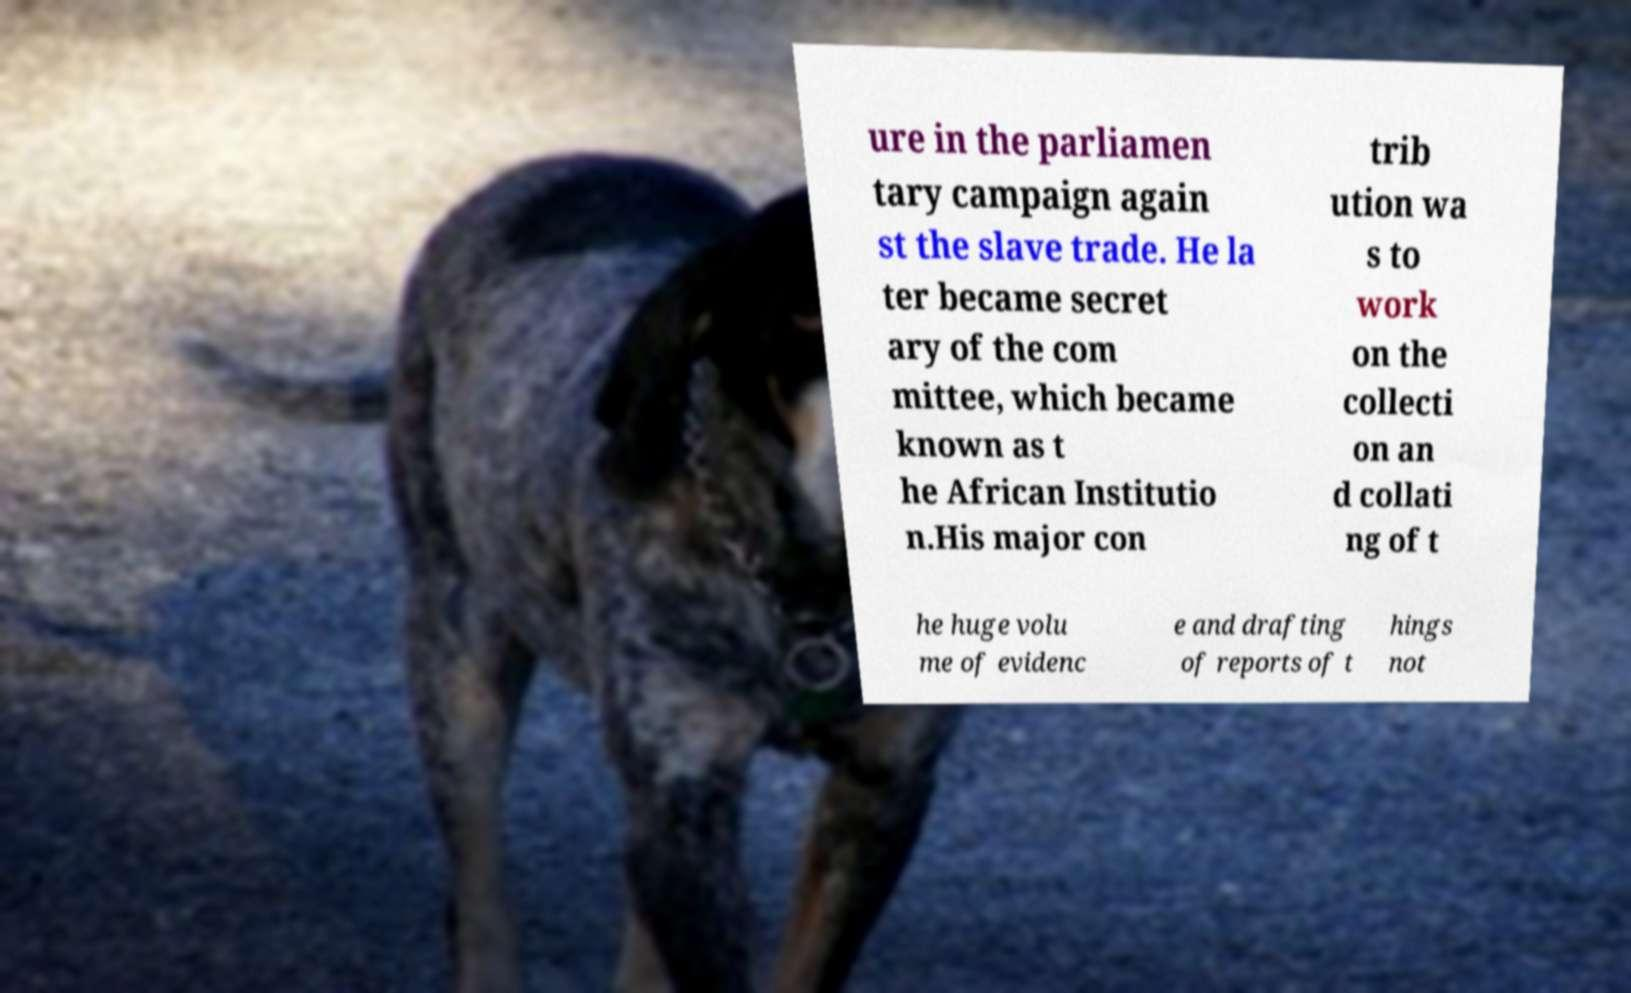For documentation purposes, I need the text within this image transcribed. Could you provide that? ure in the parliamen tary campaign again st the slave trade. He la ter became secret ary of the com mittee, which became known as t he African Institutio n.His major con trib ution wa s to work on the collecti on an d collati ng of t he huge volu me of evidenc e and drafting of reports of t hings not 